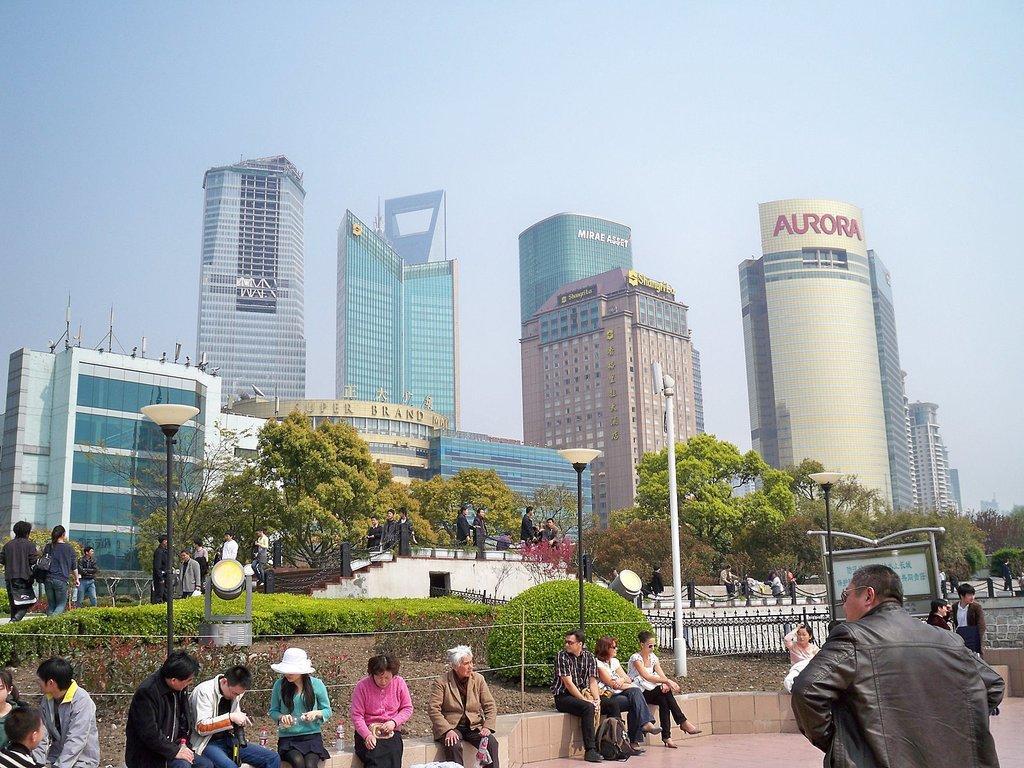Can you describe this image briefly? This picture is clicked outside the city. Here, we see many people sitting. Behind them, there are shrubs, street lights, iron railing and a board with some text written on it. In the right bottom of the picture, the man in black jacket is standing. Behind them, there are people walking and we even see a staircase. There are many trees and buildings in the background. At the top of the picture, we see the sky. 